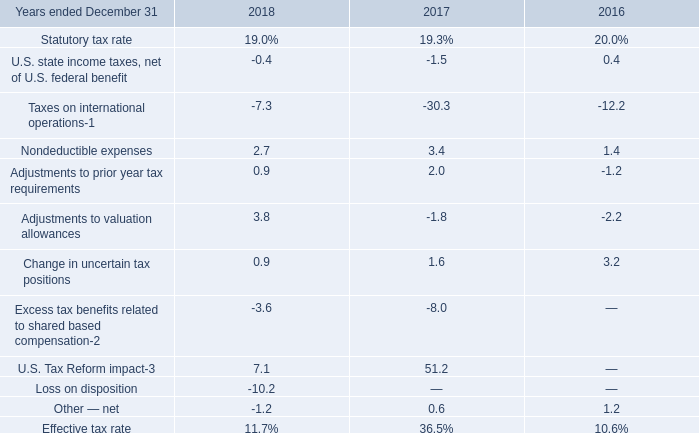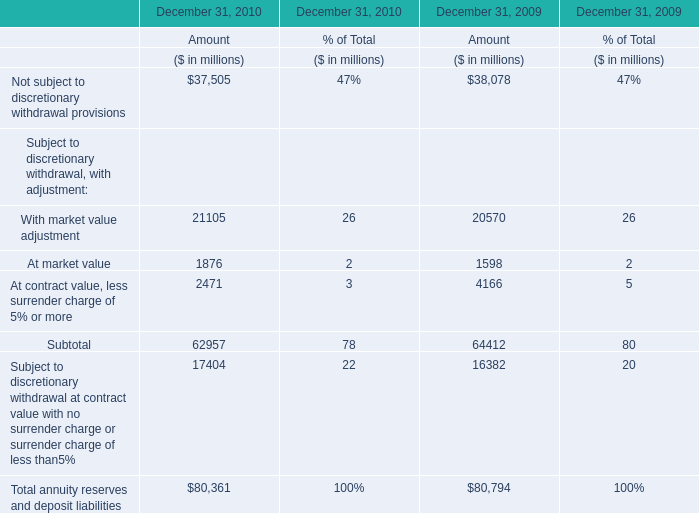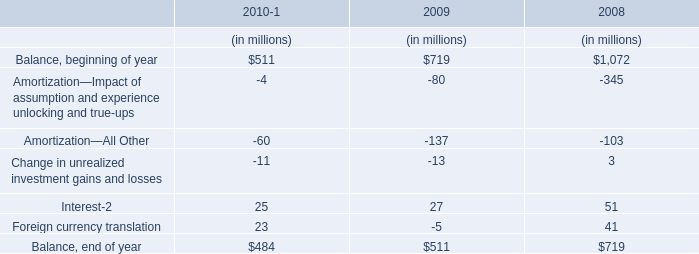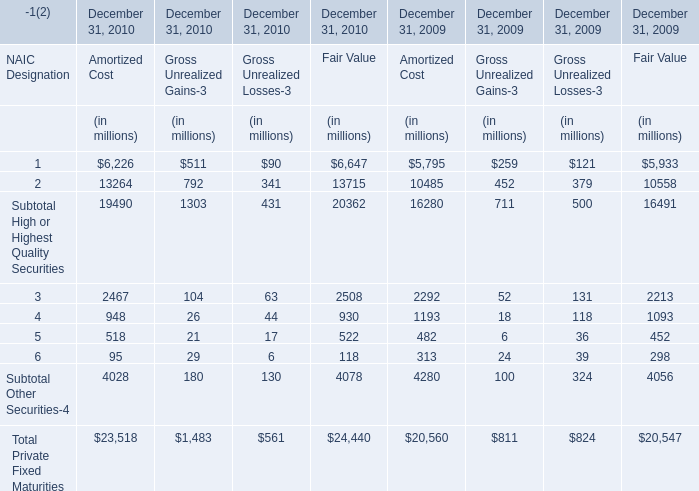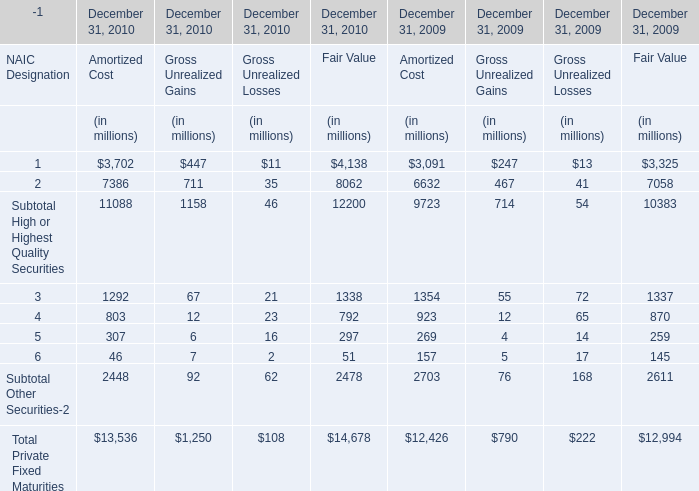What's the growth rate of Subtotal Other Securities-2 in fair value? (in %) 
Computations: ((2478 - 2611) / 2611)
Answer: -0.05094. 